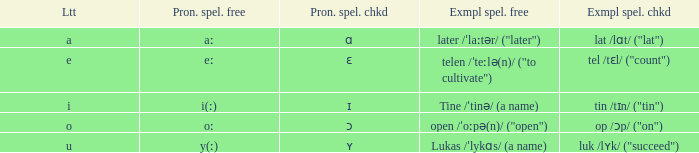What is Pronunciation Spelled Free, when Pronunciation Spelled Checked is "ʏ"? Y(ː). 